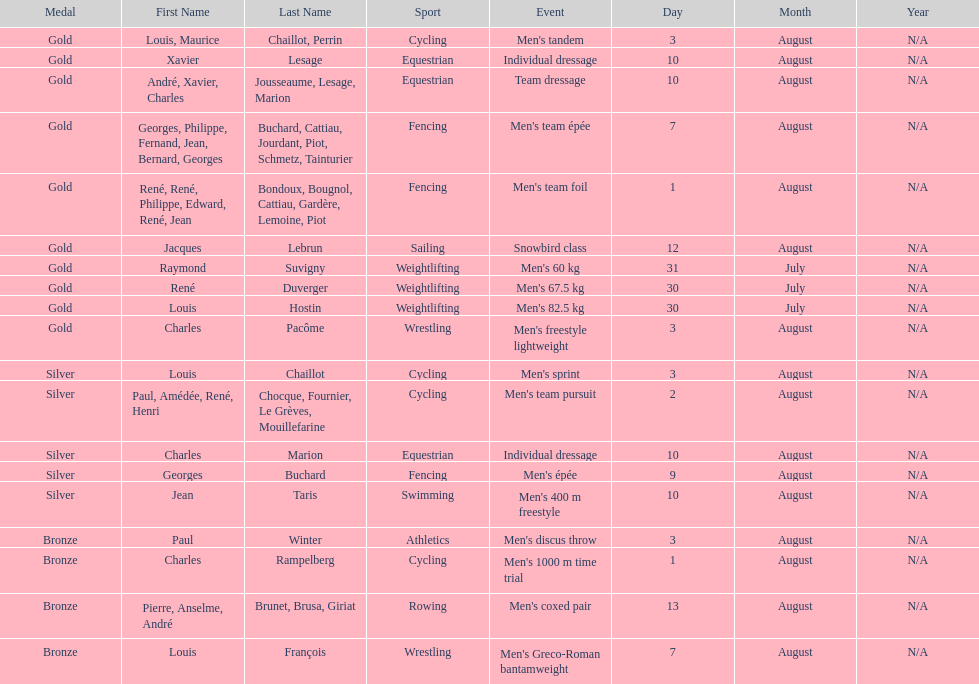How many total gold medals were won by weightlifting? 3. 